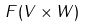<formula> <loc_0><loc_0><loc_500><loc_500>F ( V \times W )</formula> 